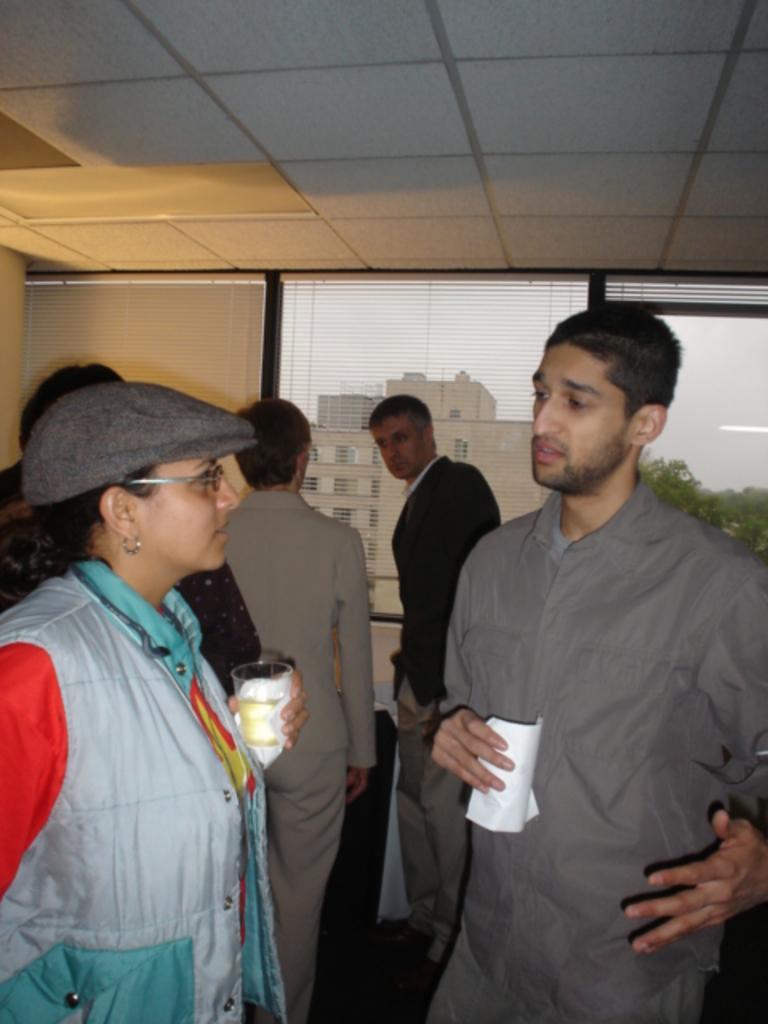Could you give a brief overview of what you see in this image? In this image we can see people standing on the floor and some of them are holding glass tumblers in their hands. In the background we can see windows, blinds, buildings, trees and sky. 